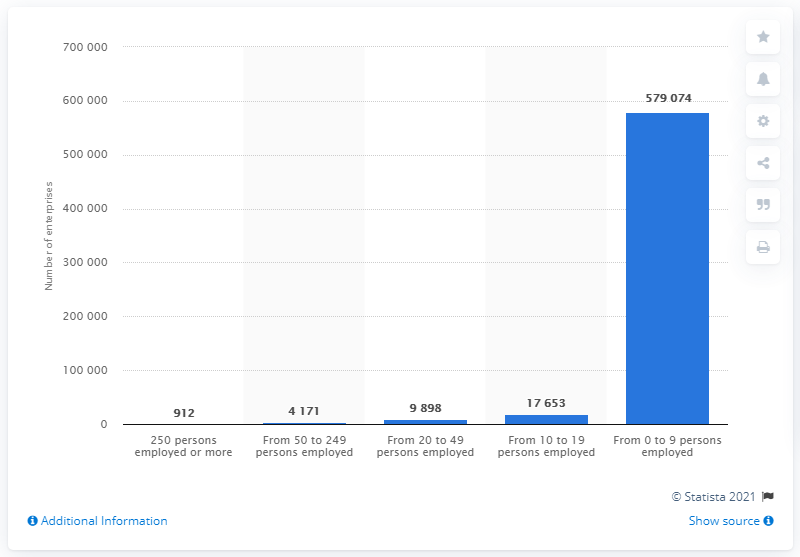Specify some key components in this picture. There were 912 enterprises in Belgium in 2016 that had 250 employees or more. 